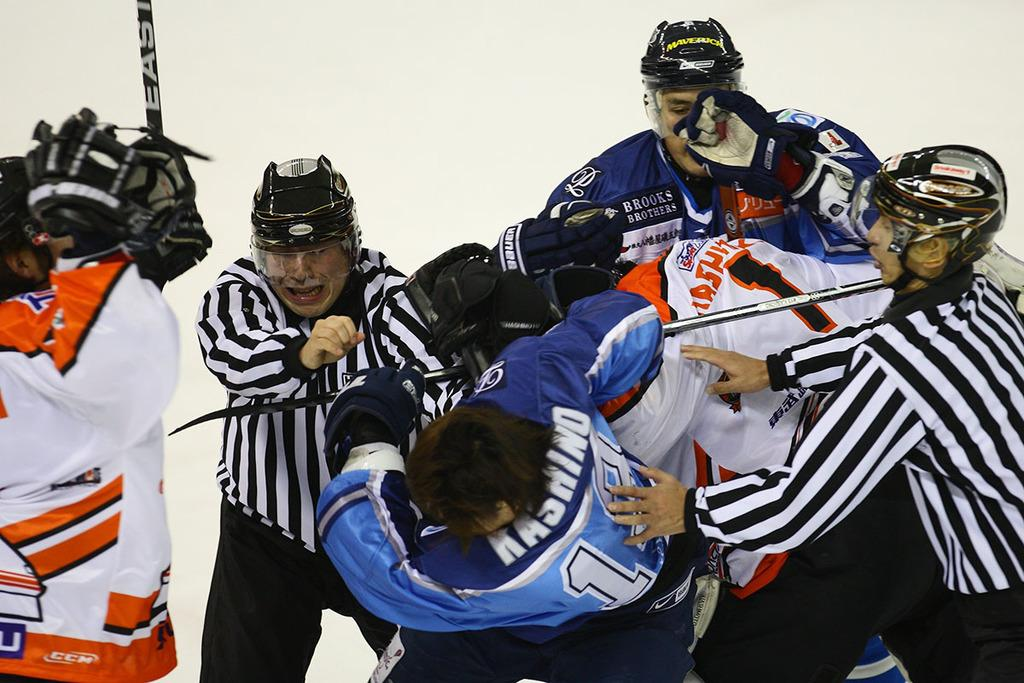What are the persons in the image wearing on their heads? The persons in the image are wearing helmets. What are the persons holding in their hands? Some persons are holding sticks in the image. What type of weather or environment is suggested by the background of the image? There is snow visible in the background of the image, suggesting a cold or wintery environment. Can you tell me who the creator of the snow is in the image? There is no specific creator of the snow depicted in the image; it is a natural occurrence. Are there any spies present in the image? There is no indication of spies or any espionage activity in the image. 